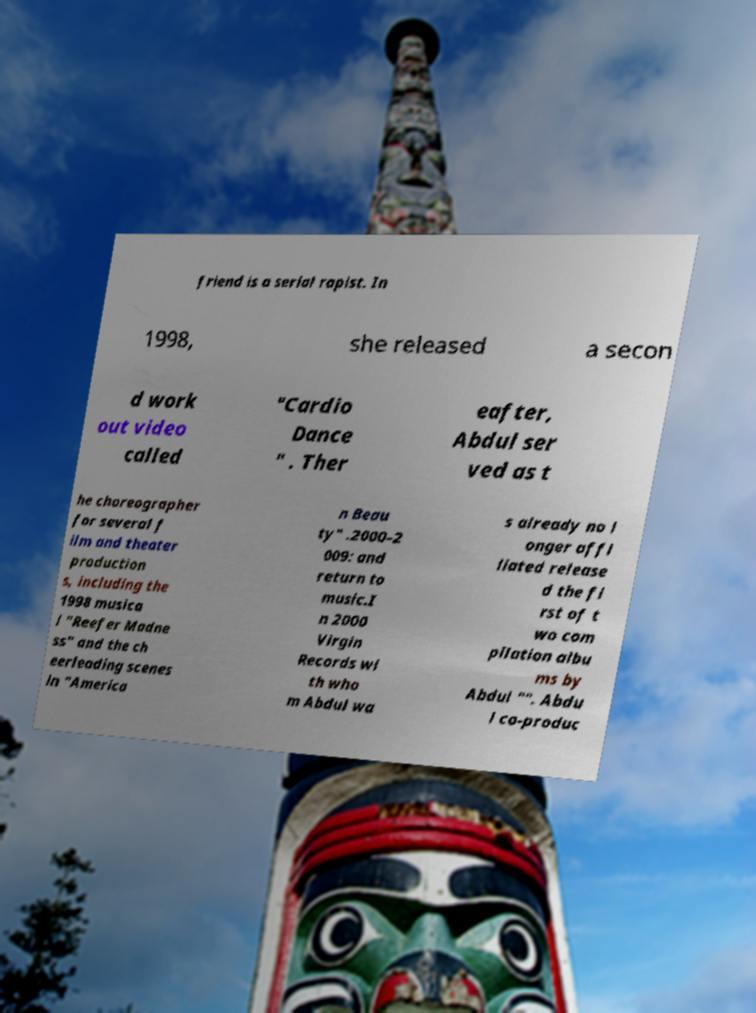What messages or text are displayed in this image? I need them in a readable, typed format. friend is a serial rapist. In 1998, she released a secon d work out video called "Cardio Dance " . Ther eafter, Abdul ser ved as t he choreographer for several f ilm and theater production s, including the 1998 musica l "Reefer Madne ss" and the ch eerleading scenes in "America n Beau ty" .2000–2 009: and return to music.I n 2000 Virgin Records wi th who m Abdul wa s already no l onger affi liated release d the fi rst of t wo com pilation albu ms by Abdul "". Abdu l co-produc 